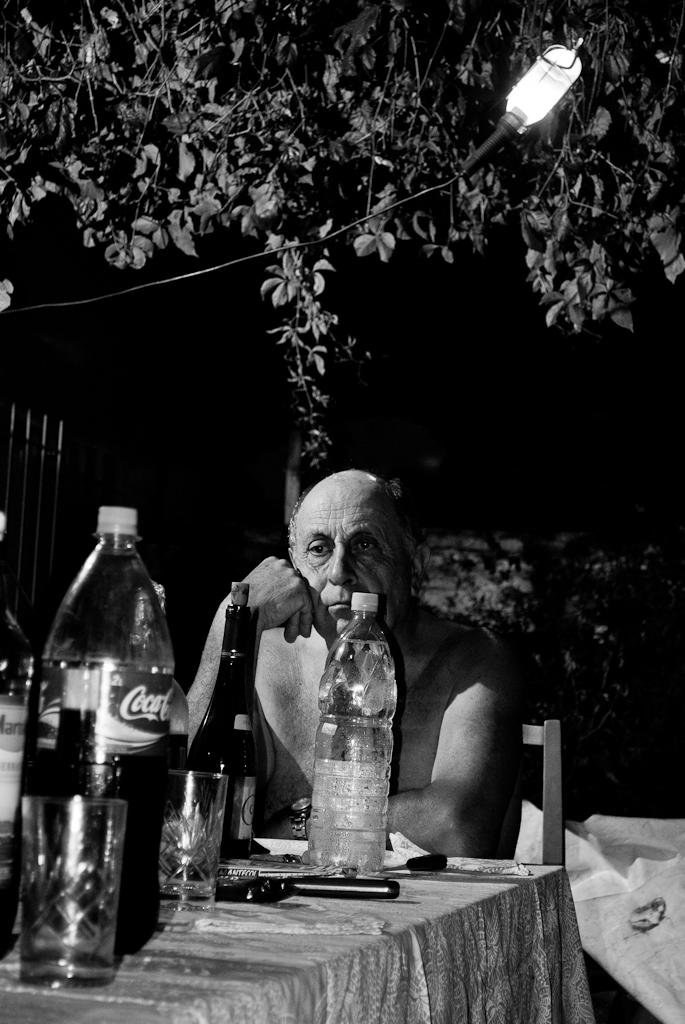<image>
Present a compact description of the photo's key features. A man sits shirtless at a table with a bottle of Coca-cola on it. 